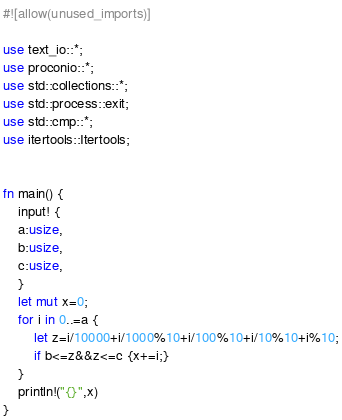Convert code to text. <code><loc_0><loc_0><loc_500><loc_500><_Rust_>#![allow(unused_imports)]

use text_io::*;
use proconio::*;
use std::collections::*;
use std::process::exit;
use std::cmp::*;
use itertools::Itertools;


fn main() {
    input! {
    a:usize,
    b:usize,
    c:usize,
    }
    let mut x=0;
    for i in 0..=a {
        let z=i/10000+i/1000%10+i/100%10+i/10%10+i%10;
        if b<=z&&z<=c {x+=i;}
    }
    println!("{}",x)
}</code> 